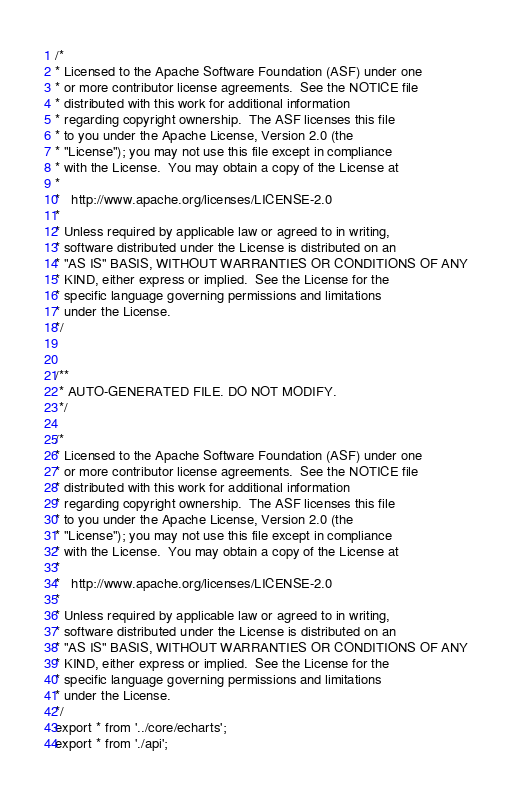<code> <loc_0><loc_0><loc_500><loc_500><_JavaScript_>
/*
* Licensed to the Apache Software Foundation (ASF) under one
* or more contributor license agreements.  See the NOTICE file
* distributed with this work for additional information
* regarding copyright ownership.  The ASF licenses this file
* to you under the Apache License, Version 2.0 (the
* "License"); you may not use this file except in compliance
* with the License.  You may obtain a copy of the License at
*
*   http://www.apache.org/licenses/LICENSE-2.0
*
* Unless required by applicable law or agreed to in writing,
* software distributed under the License is distributed on an
* "AS IS" BASIS, WITHOUT WARRANTIES OR CONDITIONS OF ANY
* KIND, either express or implied.  See the License for the
* specific language governing permissions and limitations
* under the License.
*/


/**
 * AUTO-GENERATED FILE. DO NOT MODIFY.
 */

/*
* Licensed to the Apache Software Foundation (ASF) under one
* or more contributor license agreements.  See the NOTICE file
* distributed with this work for additional information
* regarding copyright ownership.  The ASF licenses this file
* to you under the Apache License, Version 2.0 (the
* "License"); you may not use this file except in compliance
* with the License.  You may obtain a copy of the License at
*
*   http://www.apache.org/licenses/LICENSE-2.0
*
* Unless required by applicable law or agreed to in writing,
* software distributed under the License is distributed on an
* "AS IS" BASIS, WITHOUT WARRANTIES OR CONDITIONS OF ANY
* KIND, either express or implied.  See the License for the
* specific language governing permissions and limitations
* under the License.
*/
export * from '../core/echarts';
export * from './api';</code> 